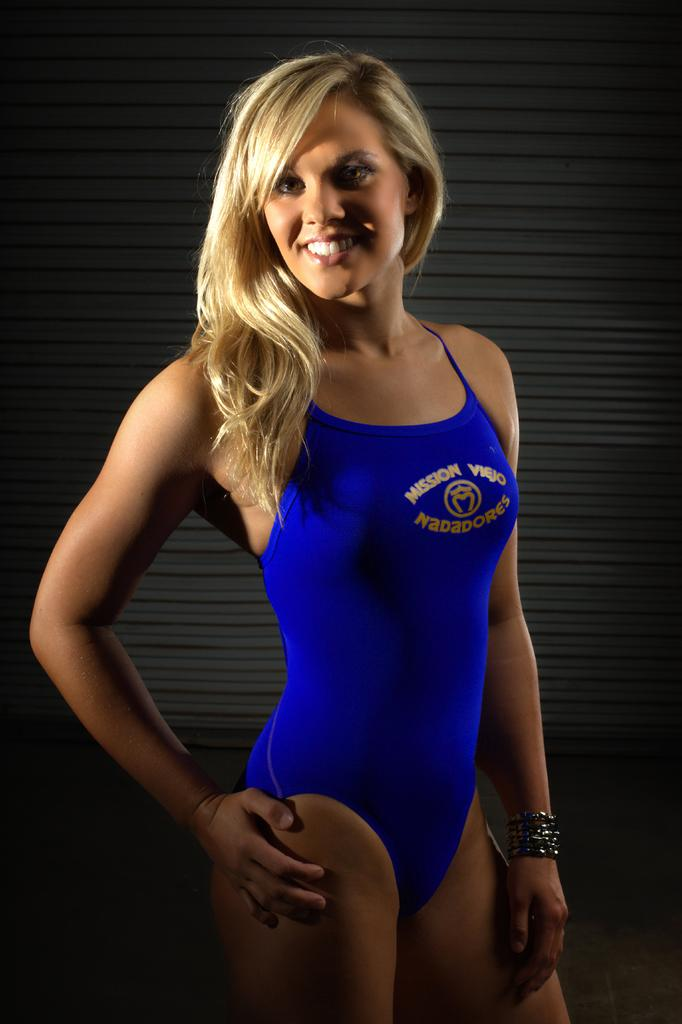Who is the main subject in the image? There is a woman in the image. What is the woman wearing? The woman is wearing a swimsuit. What expression does the woman have? The woman is smiling. What type of jam is the woman holding in the image? There is no jam present in the image; the woman is wearing a swimsuit and smiling. 